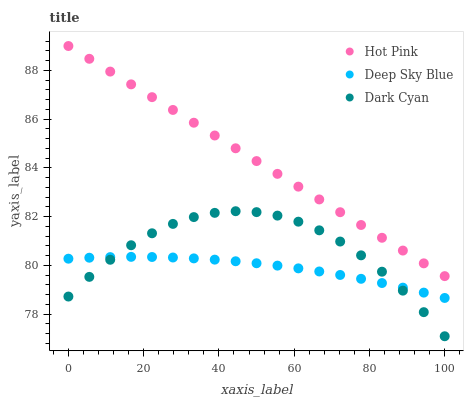Does Deep Sky Blue have the minimum area under the curve?
Answer yes or no. Yes. Does Hot Pink have the maximum area under the curve?
Answer yes or no. Yes. Does Hot Pink have the minimum area under the curve?
Answer yes or no. No. Does Deep Sky Blue have the maximum area under the curve?
Answer yes or no. No. Is Hot Pink the smoothest?
Answer yes or no. Yes. Is Dark Cyan the roughest?
Answer yes or no. Yes. Is Deep Sky Blue the smoothest?
Answer yes or no. No. Is Deep Sky Blue the roughest?
Answer yes or no. No. Does Dark Cyan have the lowest value?
Answer yes or no. Yes. Does Deep Sky Blue have the lowest value?
Answer yes or no. No. Does Hot Pink have the highest value?
Answer yes or no. Yes. Does Deep Sky Blue have the highest value?
Answer yes or no. No. Is Dark Cyan less than Hot Pink?
Answer yes or no. Yes. Is Hot Pink greater than Dark Cyan?
Answer yes or no. Yes. Does Deep Sky Blue intersect Dark Cyan?
Answer yes or no. Yes. Is Deep Sky Blue less than Dark Cyan?
Answer yes or no. No. Is Deep Sky Blue greater than Dark Cyan?
Answer yes or no. No. Does Dark Cyan intersect Hot Pink?
Answer yes or no. No. 